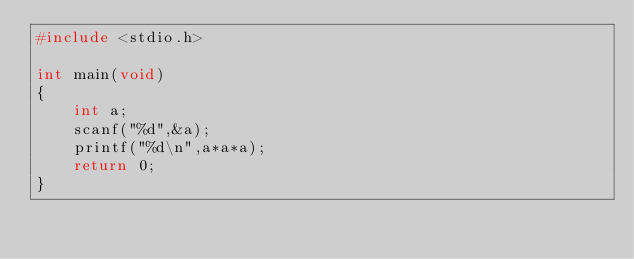Convert code to text. <code><loc_0><loc_0><loc_500><loc_500><_C_>#include <stdio.h>

int main(void)
{
	int a;
	scanf("%d",&a);
	printf("%d\n",a*a*a);
	return 0;
}</code> 